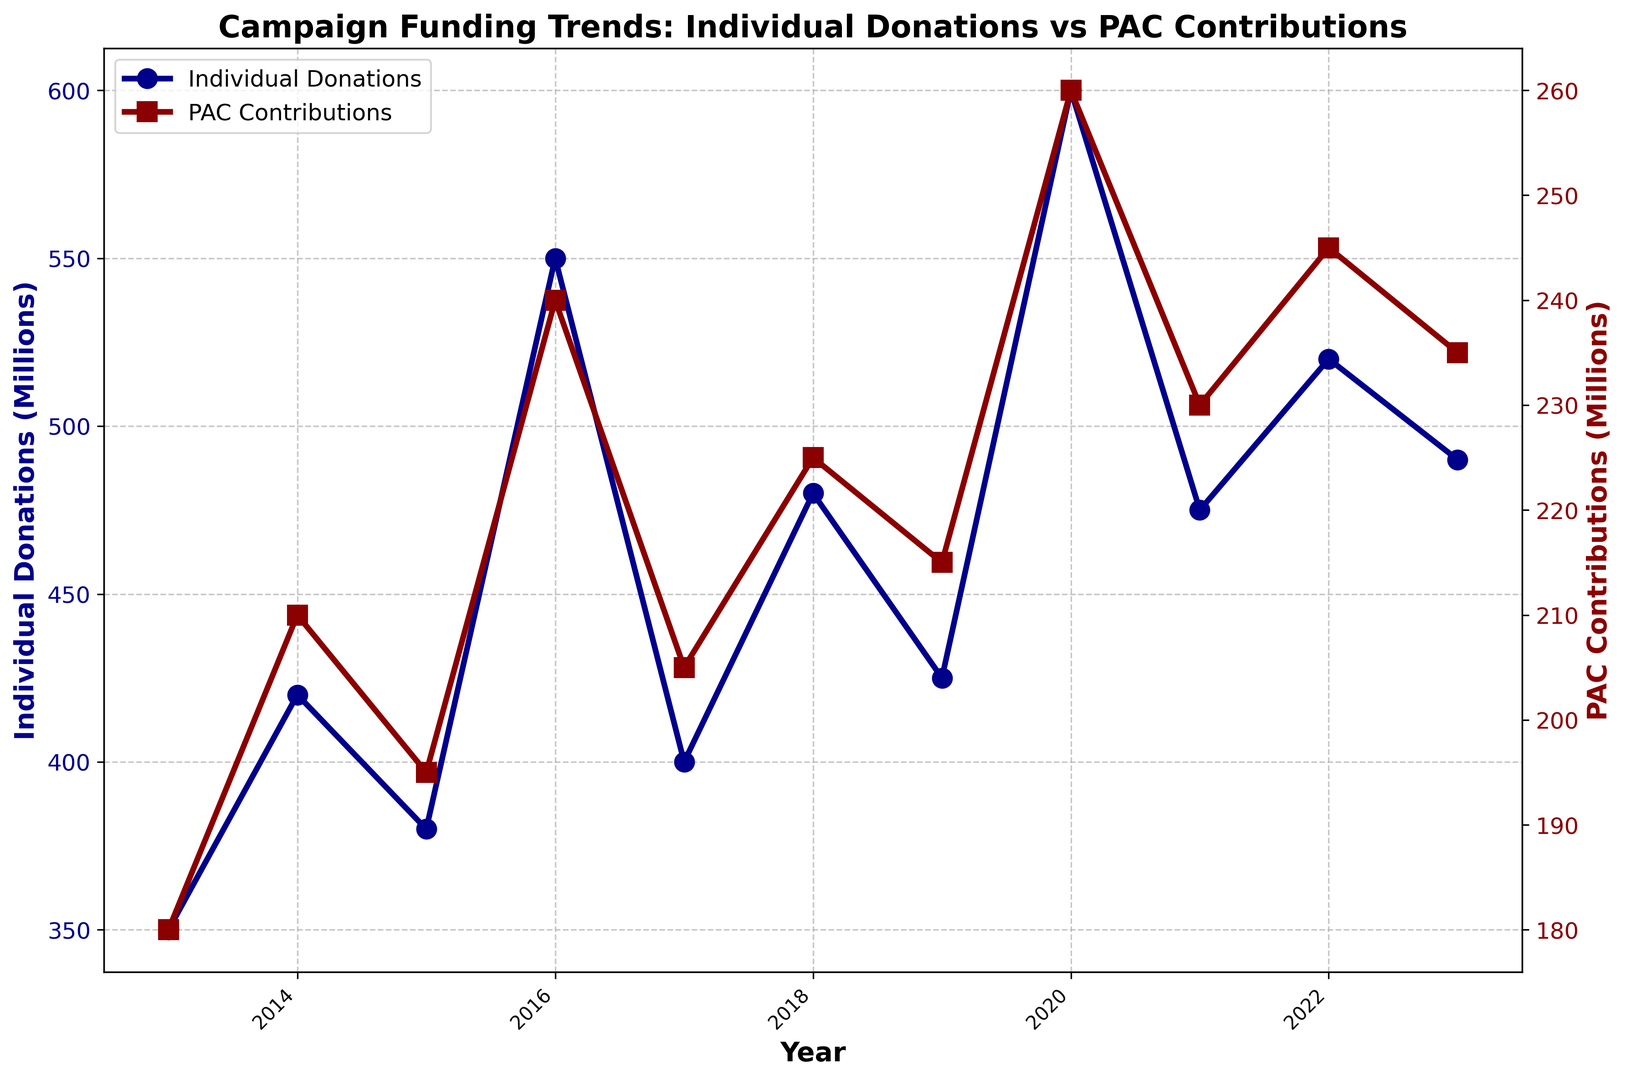Which year had the highest individual donations? To find the highest individual donations, look at the peak value on the y-axis associated with individual donations (marked in dark blue). The highest point on the graph is in 2020 with 600 million.
Answer: 2020 What is the difference in individual donations between 2020 and 2016? First, identify the individual donations for 2020 (600 million) and for 2016 (550 million). Then, subtract 550 from 600 to get the difference, which is 50 million.
Answer: 50 million In 2023, how much higher were individual donations compared to PAC contributions? Check the values for 2023: individual donations are 490 million, and PAC contributions are 235 million. The difference is 490 - 235, which equals 255 million.
Answer: 255 million Which year shows the closest value between individual donations and PAC contributions? Compare the differences between individual donations and PAC contributions for each year. In 2015, the individual donations were 380 million, and PAC contributions were 195 million, with a difference of 185 million. This is the smallest difference compared to other years.
Answer: 2015 What is the average PAC contribution over the past decade? Sum up all the PAC contributions from 2013 to 2023 (180 + 210 + 195 + 240 + 205 + 225 + 215 + 260 + 230 + 245 + 235). The total is 2435. Divide by 11 years to get the average: 2435/11 which equals 221.36 million.
Answer: 221.36 million When was the first significant increase in individual donations observed? Look at the trend line for individual donations (dark blue) and find the first significant steep increase. The first noticeable rise occurs between 2015 (380 million) and 2016 (550 million), marking a significant increase.
Answer: 2016 By how much did PAC contributions increase from 2019 to 2020? Identify the PAC contributions for 2019 (215 million) and 2020 (260 million). The increase is 260 - 215= 45 million.
Answer: 45 million Which color represents PAC contributions and how can you tell? The PAC contributions are represented by the dark red color, as seen in the graph's legend and the color of the corresponding line and markers.
Answer: Dark red Were individual donations higher in 2023 compared to 2017? By how much? Individual donations in 2023 were 490 million, and in 2017 they were 400 million. The difference is 490 - 400 which equals 90 million.
Answer: 90 million Between individual donations and PAC contributions, which showed more fluctuating trends over the decade? Examine both trend lines closely; the individual donations (dark blue) have more noticeable rises and falls compared to the more stable PAC contributions (dark red), indicating higher fluctuations.
Answer: Individual donations 